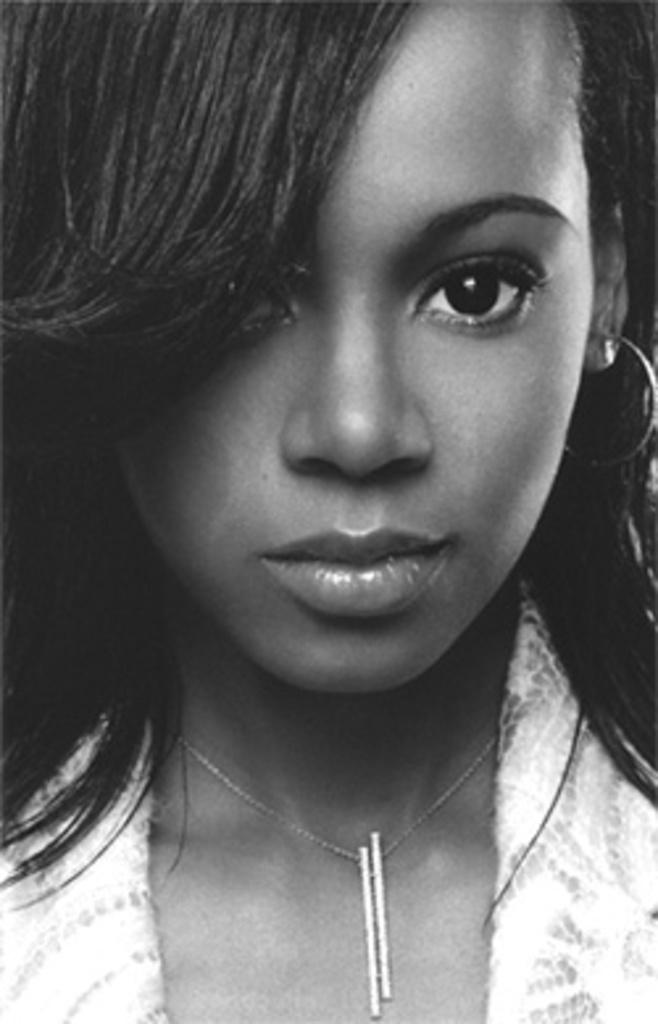What is the main subject of the image? The main subject of the image is a woman's face. What is the woman wearing in the image? The woman is wearing a white dress in the image. What scientific theory is the woman discussing in the image? There is no indication in the image that the woman is discussing any scientific theory. 